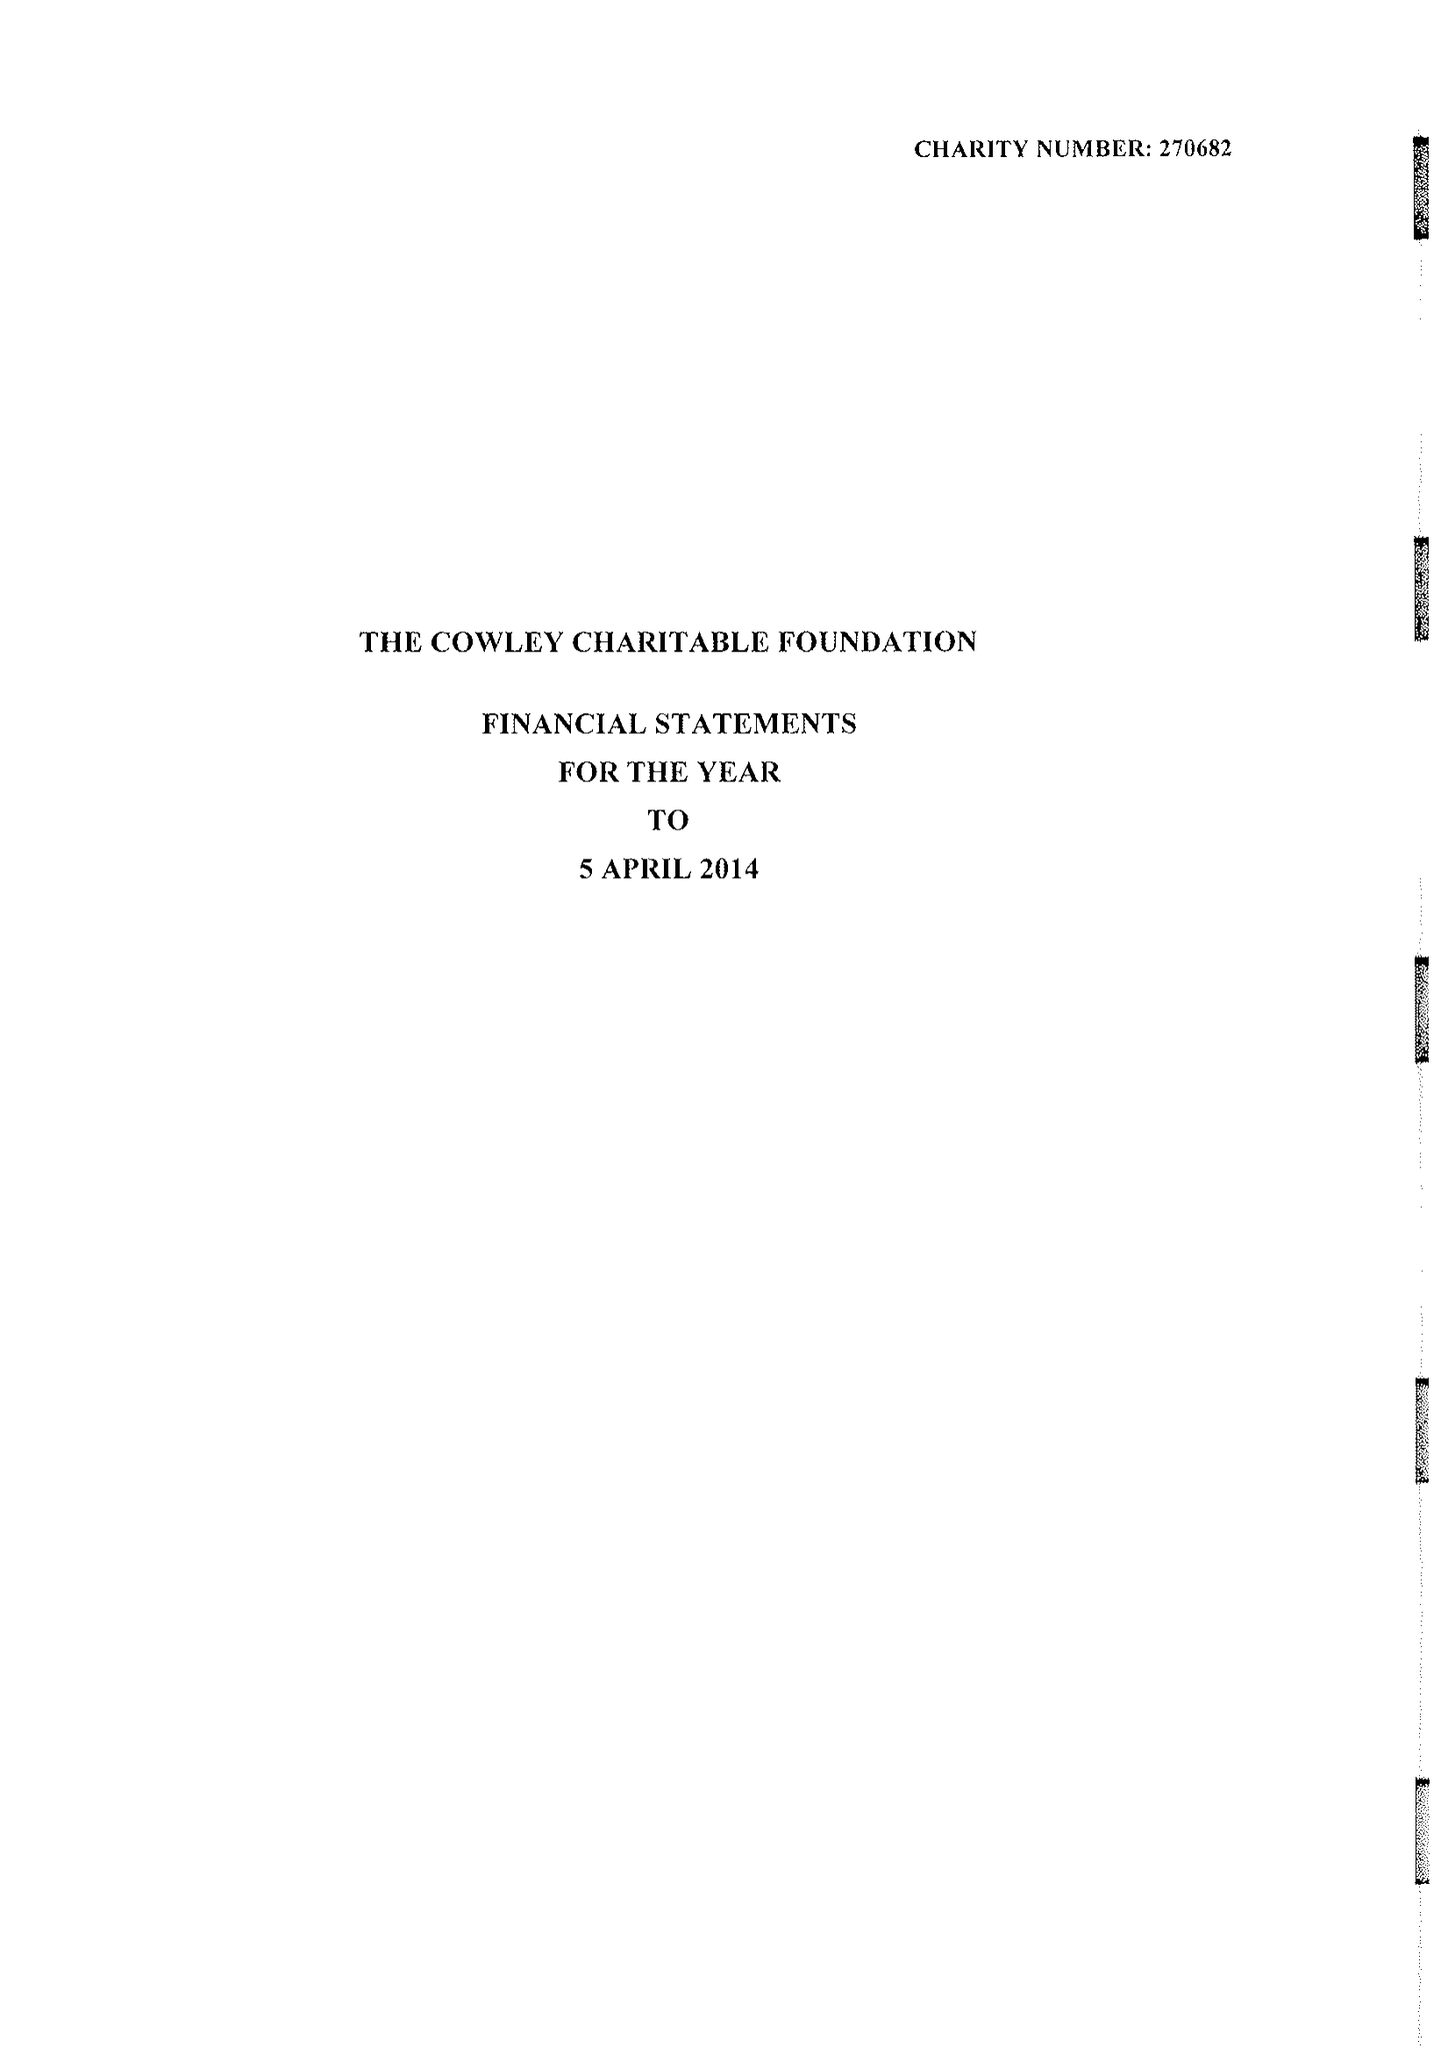What is the value for the address__post_town?
Answer the question using a single word or phrase. LONDON 